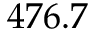Convert formula to latex. <formula><loc_0><loc_0><loc_500><loc_500>4 7 6 . 7</formula> 